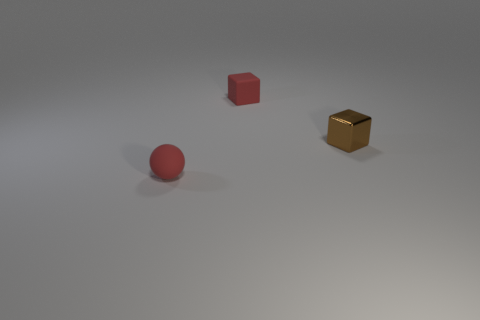What is the texture of the red sphere? The red sphere has a smooth and slightly reflective surface that hints at a rubbery or plastic material. 